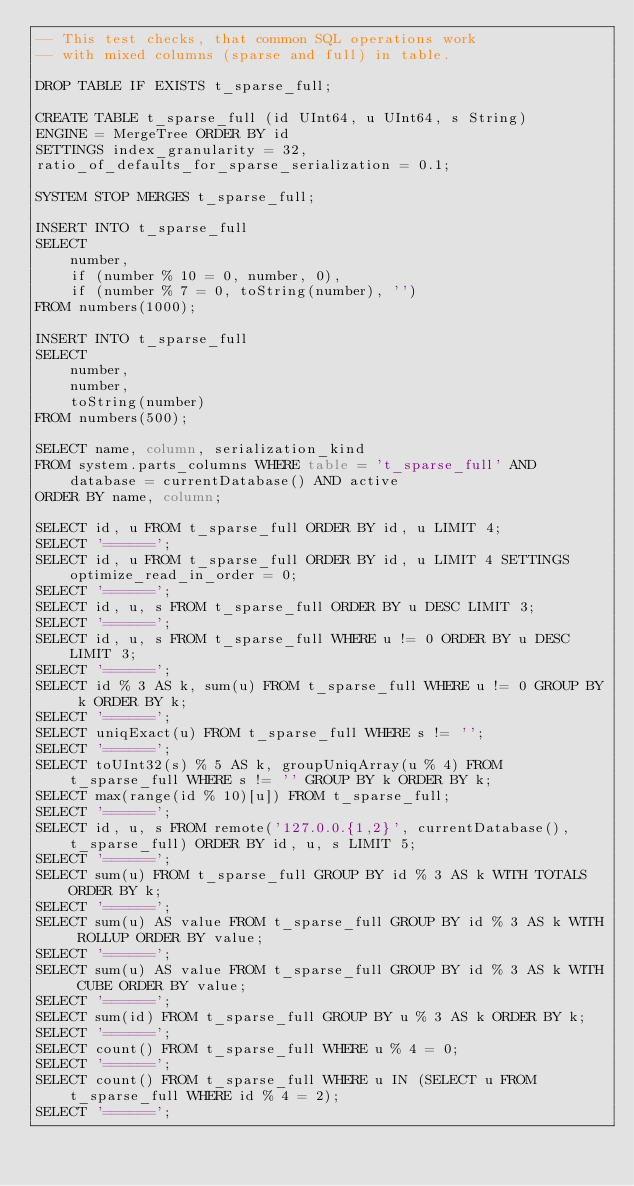Convert code to text. <code><loc_0><loc_0><loc_500><loc_500><_SQL_>-- This test checks, that common SQL operations work
-- with mixed columns (sparse and full) in table.

DROP TABLE IF EXISTS t_sparse_full;

CREATE TABLE t_sparse_full (id UInt64, u UInt64, s String)
ENGINE = MergeTree ORDER BY id
SETTINGS index_granularity = 32,
ratio_of_defaults_for_sparse_serialization = 0.1;

SYSTEM STOP MERGES t_sparse_full;

INSERT INTO t_sparse_full
SELECT
    number,
    if (number % 10 = 0, number, 0),
    if (number % 7 = 0, toString(number), '')
FROM numbers(1000);

INSERT INTO t_sparse_full
SELECT
    number,
    number,
    toString(number)
FROM numbers(500);

SELECT name, column, serialization_kind
FROM system.parts_columns WHERE table = 't_sparse_full' AND database = currentDatabase() AND active
ORDER BY name, column;

SELECT id, u FROM t_sparse_full ORDER BY id, u LIMIT 4;
SELECT '======';
SELECT id, u FROM t_sparse_full ORDER BY id, u LIMIT 4 SETTINGS optimize_read_in_order = 0;
SELECT '======';
SELECT id, u, s FROM t_sparse_full ORDER BY u DESC LIMIT 3;
SELECT '======';
SELECT id, u, s FROM t_sparse_full WHERE u != 0 ORDER BY u DESC LIMIT 3;
SELECT '======';
SELECT id % 3 AS k, sum(u) FROM t_sparse_full WHERE u != 0 GROUP BY k ORDER BY k;
SELECT '======';
SELECT uniqExact(u) FROM t_sparse_full WHERE s != '';
SELECT '======';
SELECT toUInt32(s) % 5 AS k, groupUniqArray(u % 4) FROM t_sparse_full WHERE s != '' GROUP BY k ORDER BY k;
SELECT max(range(id % 10)[u]) FROM t_sparse_full;
SELECT '======';
SELECT id, u, s FROM remote('127.0.0.{1,2}', currentDatabase(), t_sparse_full) ORDER BY id, u, s LIMIT 5;
SELECT '======';
SELECT sum(u) FROM t_sparse_full GROUP BY id % 3 AS k WITH TOTALS ORDER BY k;
SELECT '======';
SELECT sum(u) AS value FROM t_sparse_full GROUP BY id % 3 AS k WITH ROLLUP ORDER BY value;
SELECT '======';
SELECT sum(u) AS value FROM t_sparse_full GROUP BY id % 3 AS k WITH CUBE ORDER BY value;
SELECT '======';
SELECT sum(id) FROM t_sparse_full GROUP BY u % 3 AS k ORDER BY k;
SELECT '======';
SELECT count() FROM t_sparse_full WHERE u % 4 = 0;
SELECT '======';
SELECT count() FROM t_sparse_full WHERE u IN (SELECT u FROM t_sparse_full WHERE id % 4 = 2);
SELECT '======';</code> 